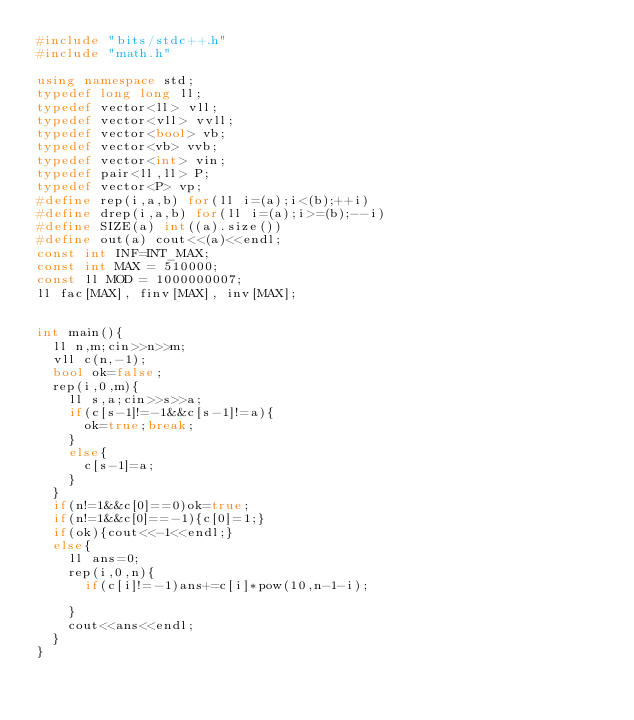<code> <loc_0><loc_0><loc_500><loc_500><_C++_>#include "bits/stdc++.h"
#include "math.h"
 
using namespace std;
typedef long long ll;
typedef vector<ll> vll;
typedef vector<vll> vvll;
typedef vector<bool> vb;
typedef vector<vb> vvb;
typedef vector<int> vin;
typedef pair<ll,ll> P;
typedef vector<P> vp;
#define rep(i,a,b) for(ll i=(a);i<(b);++i)
#define drep(i,a,b) for(ll i=(a);i>=(b);--i)
#define SIZE(a) int((a).size())
#define out(a) cout<<(a)<<endl;
const int INF=INT_MAX;
const int MAX = 510000;
const ll MOD = 1000000007;
ll fac[MAX], finv[MAX], inv[MAX];


int main(){
  ll n,m;cin>>n>>m;
  vll c(n,-1);
  bool ok=false;
  rep(i,0,m){
    ll s,a;cin>>s>>a;
    if(c[s-1]!=-1&&c[s-1]!=a){
      ok=true;break;
    }
    else{
      c[s-1]=a;
    }
  }
  if(n!=1&&c[0]==0)ok=true;
  if(n!=1&&c[0]==-1){c[0]=1;}
  if(ok){cout<<-1<<endl;}
  else{
    ll ans=0;
    rep(i,0,n){
      if(c[i]!=-1)ans+=c[i]*pow(10,n-1-i);
      
    }
    cout<<ans<<endl;
  }
}




</code> 